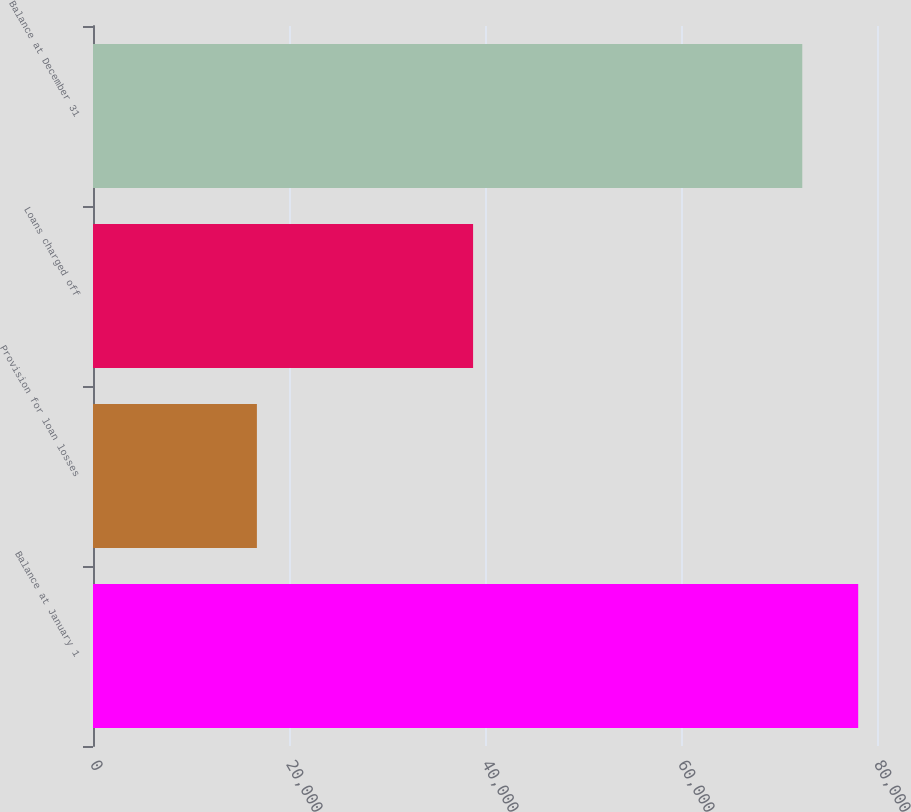Convert chart to OTSL. <chart><loc_0><loc_0><loc_500><loc_500><bar_chart><fcel>Balance at January 1<fcel>Provision for loan losses<fcel>Loans charged off<fcel>Balance at December 31<nl><fcel>78082.6<fcel>16724<fcel>38785<fcel>72375<nl></chart> 